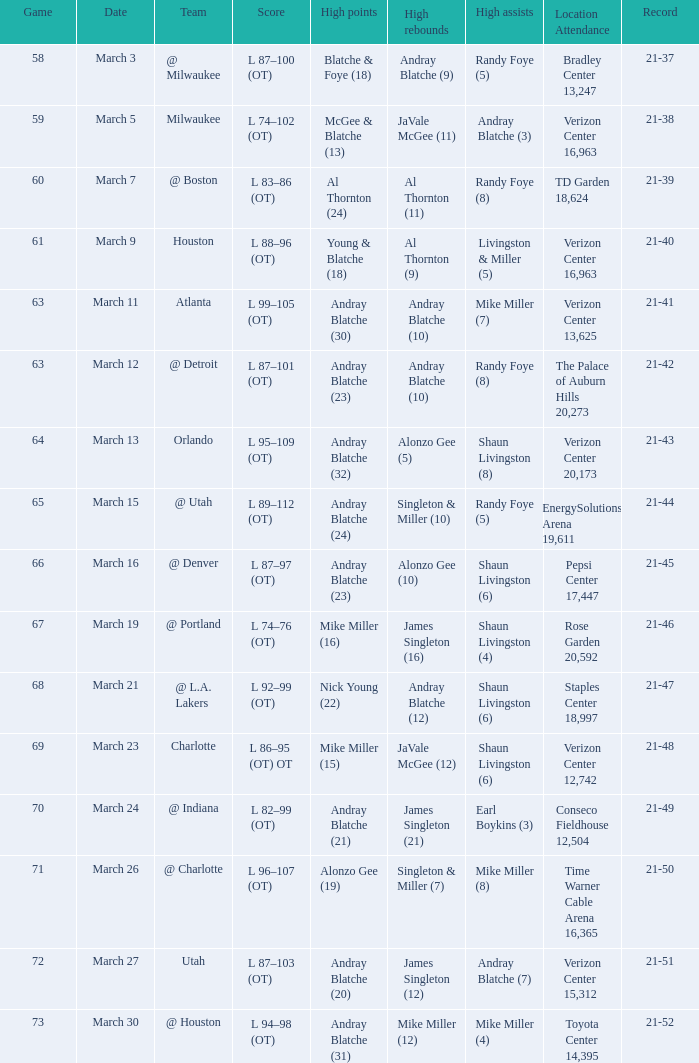Could you help me parse every detail presented in this table? {'header': ['Game', 'Date', 'Team', 'Score', 'High points', 'High rebounds', 'High assists', 'Location Attendance', 'Record'], 'rows': [['58', 'March 3', '@ Milwaukee', 'L 87–100 (OT)', 'Blatche & Foye (18)', 'Andray Blatche (9)', 'Randy Foye (5)', 'Bradley Center 13,247', '21-37'], ['59', 'March 5', 'Milwaukee', 'L 74–102 (OT)', 'McGee & Blatche (13)', 'JaVale McGee (11)', 'Andray Blatche (3)', 'Verizon Center 16,963', '21-38'], ['60', 'March 7', '@ Boston', 'L 83–86 (OT)', 'Al Thornton (24)', 'Al Thornton (11)', 'Randy Foye (8)', 'TD Garden 18,624', '21-39'], ['61', 'March 9', 'Houston', 'L 88–96 (OT)', 'Young & Blatche (18)', 'Al Thornton (9)', 'Livingston & Miller (5)', 'Verizon Center 16,963', '21-40'], ['63', 'March 11', 'Atlanta', 'L 99–105 (OT)', 'Andray Blatche (30)', 'Andray Blatche (10)', 'Mike Miller (7)', 'Verizon Center 13,625', '21-41'], ['63', 'March 12', '@ Detroit', 'L 87–101 (OT)', 'Andray Blatche (23)', 'Andray Blatche (10)', 'Randy Foye (8)', 'The Palace of Auburn Hills 20,273', '21-42'], ['64', 'March 13', 'Orlando', 'L 95–109 (OT)', 'Andray Blatche (32)', 'Alonzo Gee (5)', 'Shaun Livingston (8)', 'Verizon Center 20,173', '21-43'], ['65', 'March 15', '@ Utah', 'L 89–112 (OT)', 'Andray Blatche (24)', 'Singleton & Miller (10)', 'Randy Foye (5)', 'EnergySolutions Arena 19,611', '21-44'], ['66', 'March 16', '@ Denver', 'L 87–97 (OT)', 'Andray Blatche (23)', 'Alonzo Gee (10)', 'Shaun Livingston (6)', 'Pepsi Center 17,447', '21-45'], ['67', 'March 19', '@ Portland', 'L 74–76 (OT)', 'Mike Miller (16)', 'James Singleton (16)', 'Shaun Livingston (4)', 'Rose Garden 20,592', '21-46'], ['68', 'March 21', '@ L.A. Lakers', 'L 92–99 (OT)', 'Nick Young (22)', 'Andray Blatche (12)', 'Shaun Livingston (6)', 'Staples Center 18,997', '21-47'], ['69', 'March 23', 'Charlotte', 'L 86–95 (OT) OT', 'Mike Miller (15)', 'JaVale McGee (12)', 'Shaun Livingston (6)', 'Verizon Center 12,742', '21-48'], ['70', 'March 24', '@ Indiana', 'L 82–99 (OT)', 'Andray Blatche (21)', 'James Singleton (21)', 'Earl Boykins (3)', 'Conseco Fieldhouse 12,504', '21-49'], ['71', 'March 26', '@ Charlotte', 'L 96–107 (OT)', 'Alonzo Gee (19)', 'Singleton & Miller (7)', 'Mike Miller (8)', 'Time Warner Cable Arena 16,365', '21-50'], ['72', 'March 27', 'Utah', 'L 87–103 (OT)', 'Andray Blatche (20)', 'James Singleton (12)', 'Andray Blatche (7)', 'Verizon Center 15,312', '21-51'], ['73', 'March 30', '@ Houston', 'L 94–98 (OT)', 'Andray Blatche (31)', 'Mike Miller (12)', 'Mike Miller (4)', 'Toyota Center 14,395', '21-52']]} On what date was the attendance at TD Garden 18,624? March 7. 